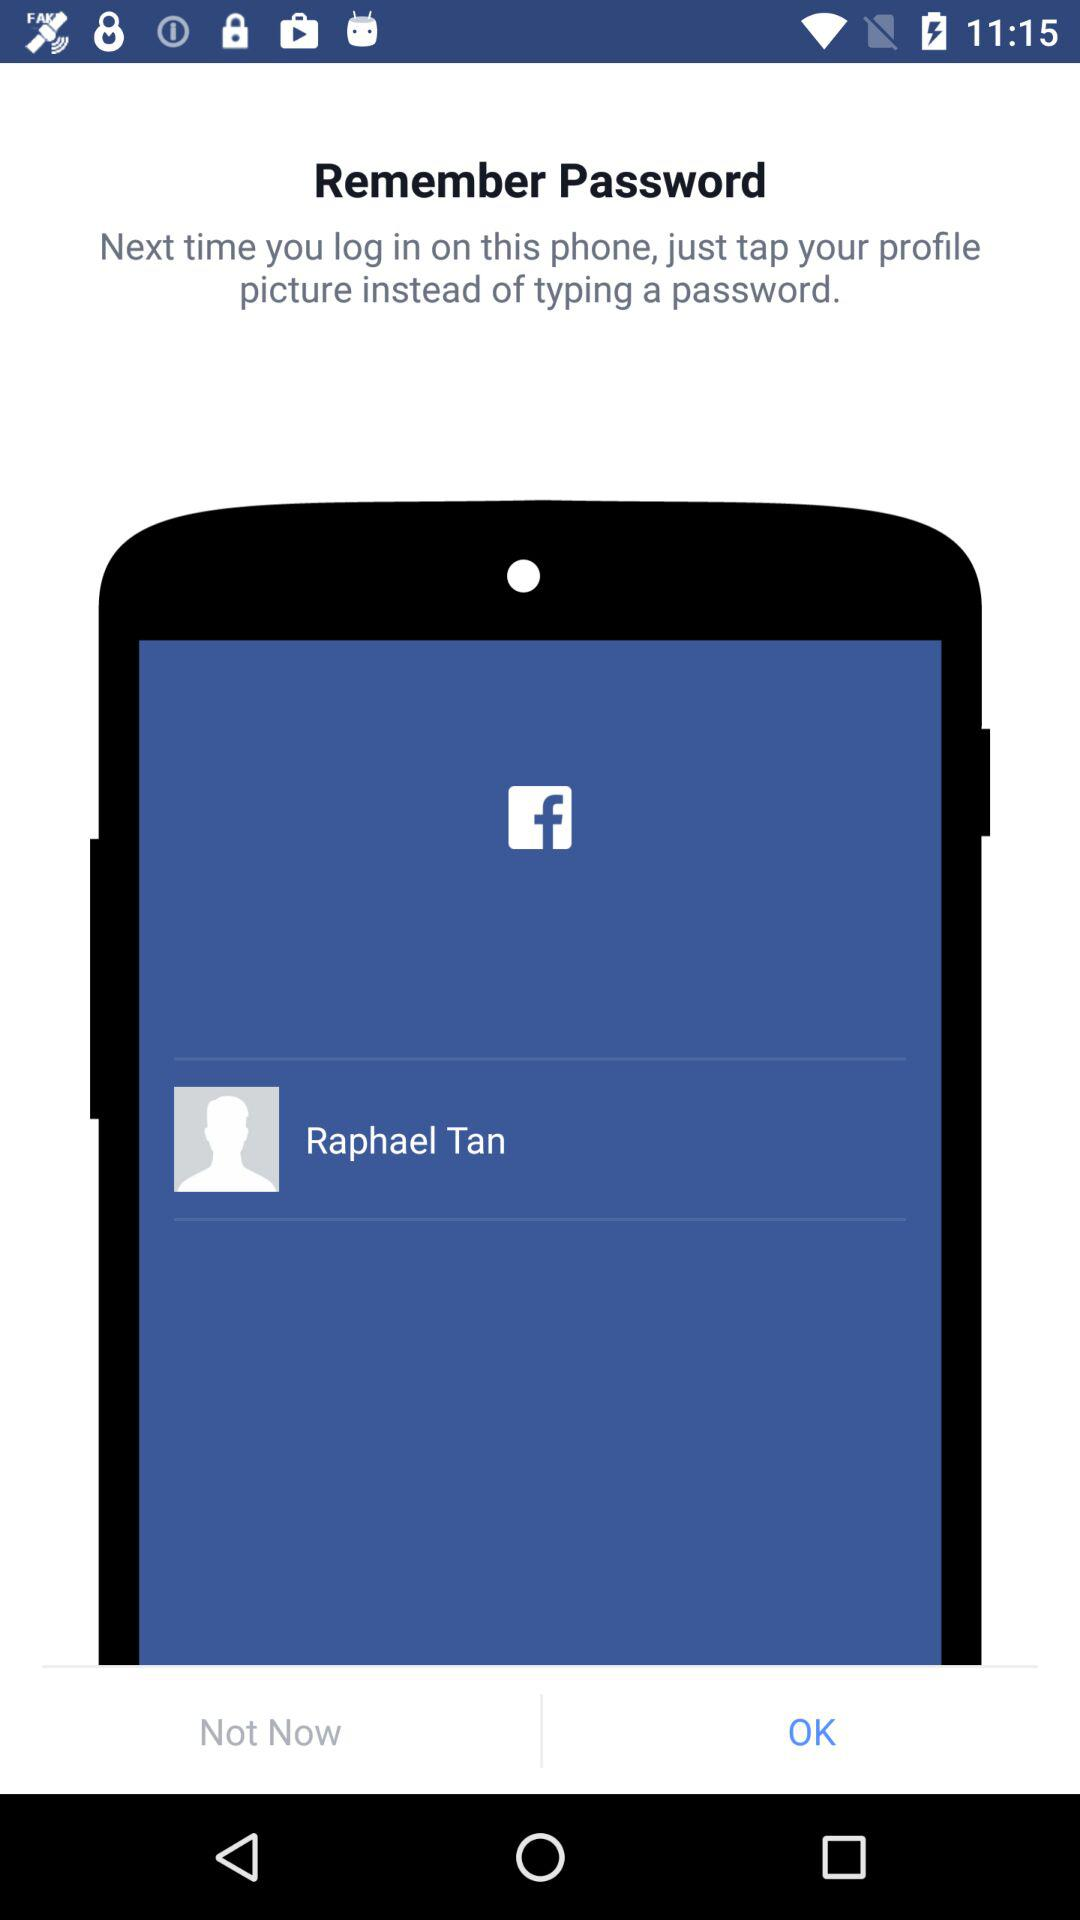What is the user name? The user name is Raphael Tan. 